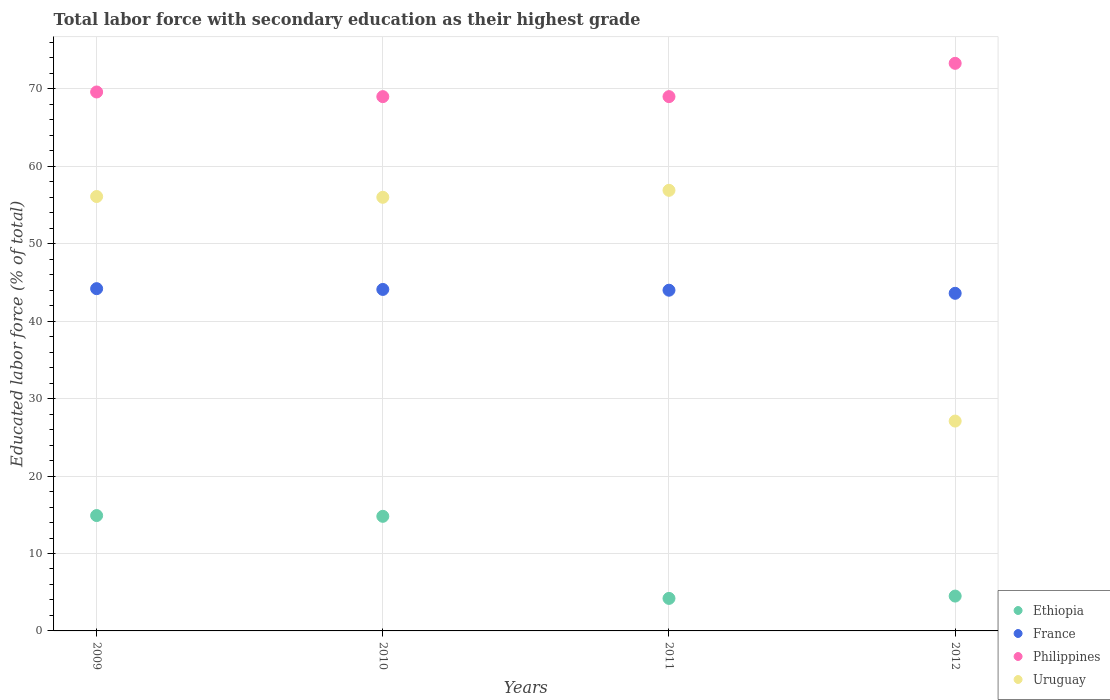What is the percentage of total labor force with primary education in Philippines in 2010?
Give a very brief answer. 69. Across all years, what is the maximum percentage of total labor force with primary education in Ethiopia?
Give a very brief answer. 14.9. Across all years, what is the minimum percentage of total labor force with primary education in Uruguay?
Your answer should be very brief. 27.1. In which year was the percentage of total labor force with primary education in Ethiopia maximum?
Give a very brief answer. 2009. What is the total percentage of total labor force with primary education in Ethiopia in the graph?
Ensure brevity in your answer.  38.4. What is the difference between the percentage of total labor force with primary education in Uruguay in 2009 and that in 2012?
Keep it short and to the point. 29. What is the difference between the percentage of total labor force with primary education in Ethiopia in 2010 and the percentage of total labor force with primary education in Philippines in 2009?
Make the answer very short. -54.8. What is the average percentage of total labor force with primary education in France per year?
Keep it short and to the point. 43.97. In the year 2009, what is the difference between the percentage of total labor force with primary education in Uruguay and percentage of total labor force with primary education in Ethiopia?
Offer a terse response. 41.2. What is the ratio of the percentage of total labor force with primary education in Ethiopia in 2009 to that in 2012?
Your answer should be very brief. 3.31. Is the percentage of total labor force with primary education in Uruguay in 2011 less than that in 2012?
Make the answer very short. No. What is the difference between the highest and the second highest percentage of total labor force with primary education in Uruguay?
Offer a very short reply. 0.8. What is the difference between the highest and the lowest percentage of total labor force with primary education in Ethiopia?
Keep it short and to the point. 10.7. Is the sum of the percentage of total labor force with primary education in Philippines in 2009 and 2010 greater than the maximum percentage of total labor force with primary education in Uruguay across all years?
Make the answer very short. Yes. Is it the case that in every year, the sum of the percentage of total labor force with primary education in Ethiopia and percentage of total labor force with primary education in France  is greater than the percentage of total labor force with primary education in Uruguay?
Provide a short and direct response. No. Is the percentage of total labor force with primary education in Philippines strictly greater than the percentage of total labor force with primary education in Uruguay over the years?
Provide a short and direct response. Yes. How many dotlines are there?
Provide a short and direct response. 4. How many years are there in the graph?
Give a very brief answer. 4. What is the difference between two consecutive major ticks on the Y-axis?
Keep it short and to the point. 10. Are the values on the major ticks of Y-axis written in scientific E-notation?
Your response must be concise. No. Does the graph contain any zero values?
Provide a succinct answer. No. Does the graph contain grids?
Your answer should be compact. Yes. How are the legend labels stacked?
Ensure brevity in your answer.  Vertical. What is the title of the graph?
Make the answer very short. Total labor force with secondary education as their highest grade. Does "French Polynesia" appear as one of the legend labels in the graph?
Provide a succinct answer. No. What is the label or title of the Y-axis?
Your answer should be very brief. Educated labor force (% of total). What is the Educated labor force (% of total) of Ethiopia in 2009?
Keep it short and to the point. 14.9. What is the Educated labor force (% of total) of France in 2009?
Your answer should be compact. 44.2. What is the Educated labor force (% of total) of Philippines in 2009?
Make the answer very short. 69.6. What is the Educated labor force (% of total) in Uruguay in 2009?
Provide a succinct answer. 56.1. What is the Educated labor force (% of total) in Ethiopia in 2010?
Your response must be concise. 14.8. What is the Educated labor force (% of total) in France in 2010?
Give a very brief answer. 44.1. What is the Educated labor force (% of total) in Ethiopia in 2011?
Your answer should be compact. 4.2. What is the Educated labor force (% of total) in France in 2011?
Your answer should be compact. 44. What is the Educated labor force (% of total) in Philippines in 2011?
Offer a terse response. 69. What is the Educated labor force (% of total) in Uruguay in 2011?
Provide a short and direct response. 56.9. What is the Educated labor force (% of total) of Ethiopia in 2012?
Provide a short and direct response. 4.5. What is the Educated labor force (% of total) of France in 2012?
Offer a terse response. 43.6. What is the Educated labor force (% of total) in Philippines in 2012?
Give a very brief answer. 73.3. What is the Educated labor force (% of total) of Uruguay in 2012?
Provide a succinct answer. 27.1. Across all years, what is the maximum Educated labor force (% of total) of Ethiopia?
Provide a short and direct response. 14.9. Across all years, what is the maximum Educated labor force (% of total) in France?
Your answer should be very brief. 44.2. Across all years, what is the maximum Educated labor force (% of total) in Philippines?
Make the answer very short. 73.3. Across all years, what is the maximum Educated labor force (% of total) in Uruguay?
Keep it short and to the point. 56.9. Across all years, what is the minimum Educated labor force (% of total) of Ethiopia?
Your answer should be very brief. 4.2. Across all years, what is the minimum Educated labor force (% of total) in France?
Offer a terse response. 43.6. Across all years, what is the minimum Educated labor force (% of total) in Uruguay?
Keep it short and to the point. 27.1. What is the total Educated labor force (% of total) of Ethiopia in the graph?
Give a very brief answer. 38.4. What is the total Educated labor force (% of total) in France in the graph?
Provide a succinct answer. 175.9. What is the total Educated labor force (% of total) of Philippines in the graph?
Ensure brevity in your answer.  280.9. What is the total Educated labor force (% of total) in Uruguay in the graph?
Provide a short and direct response. 196.1. What is the difference between the Educated labor force (% of total) of Philippines in 2009 and that in 2010?
Your response must be concise. 0.6. What is the difference between the Educated labor force (% of total) of Uruguay in 2009 and that in 2010?
Ensure brevity in your answer.  0.1. What is the difference between the Educated labor force (% of total) in Ethiopia in 2009 and that in 2011?
Ensure brevity in your answer.  10.7. What is the difference between the Educated labor force (% of total) of Uruguay in 2009 and that in 2011?
Provide a succinct answer. -0.8. What is the difference between the Educated labor force (% of total) of Ethiopia in 2009 and that in 2012?
Make the answer very short. 10.4. What is the difference between the Educated labor force (% of total) in Philippines in 2009 and that in 2012?
Your answer should be compact. -3.7. What is the difference between the Educated labor force (% of total) of France in 2010 and that in 2011?
Offer a very short reply. 0.1. What is the difference between the Educated labor force (% of total) in Philippines in 2010 and that in 2011?
Your answer should be compact. 0. What is the difference between the Educated labor force (% of total) of Uruguay in 2010 and that in 2011?
Your answer should be very brief. -0.9. What is the difference between the Educated labor force (% of total) in France in 2010 and that in 2012?
Offer a terse response. 0.5. What is the difference between the Educated labor force (% of total) in Uruguay in 2010 and that in 2012?
Provide a succinct answer. 28.9. What is the difference between the Educated labor force (% of total) in Ethiopia in 2011 and that in 2012?
Offer a terse response. -0.3. What is the difference between the Educated labor force (% of total) of France in 2011 and that in 2012?
Your answer should be very brief. 0.4. What is the difference between the Educated labor force (% of total) of Philippines in 2011 and that in 2012?
Keep it short and to the point. -4.3. What is the difference between the Educated labor force (% of total) in Uruguay in 2011 and that in 2012?
Offer a terse response. 29.8. What is the difference between the Educated labor force (% of total) in Ethiopia in 2009 and the Educated labor force (% of total) in France in 2010?
Give a very brief answer. -29.2. What is the difference between the Educated labor force (% of total) of Ethiopia in 2009 and the Educated labor force (% of total) of Philippines in 2010?
Keep it short and to the point. -54.1. What is the difference between the Educated labor force (% of total) of Ethiopia in 2009 and the Educated labor force (% of total) of Uruguay in 2010?
Offer a terse response. -41.1. What is the difference between the Educated labor force (% of total) in France in 2009 and the Educated labor force (% of total) in Philippines in 2010?
Offer a terse response. -24.8. What is the difference between the Educated labor force (% of total) in Philippines in 2009 and the Educated labor force (% of total) in Uruguay in 2010?
Keep it short and to the point. 13.6. What is the difference between the Educated labor force (% of total) in Ethiopia in 2009 and the Educated labor force (% of total) in France in 2011?
Your answer should be very brief. -29.1. What is the difference between the Educated labor force (% of total) in Ethiopia in 2009 and the Educated labor force (% of total) in Philippines in 2011?
Make the answer very short. -54.1. What is the difference between the Educated labor force (% of total) of Ethiopia in 2009 and the Educated labor force (% of total) of Uruguay in 2011?
Provide a short and direct response. -42. What is the difference between the Educated labor force (% of total) of France in 2009 and the Educated labor force (% of total) of Philippines in 2011?
Give a very brief answer. -24.8. What is the difference between the Educated labor force (% of total) of France in 2009 and the Educated labor force (% of total) of Uruguay in 2011?
Provide a short and direct response. -12.7. What is the difference between the Educated labor force (% of total) in Ethiopia in 2009 and the Educated labor force (% of total) in France in 2012?
Offer a terse response. -28.7. What is the difference between the Educated labor force (% of total) of Ethiopia in 2009 and the Educated labor force (% of total) of Philippines in 2012?
Keep it short and to the point. -58.4. What is the difference between the Educated labor force (% of total) of Ethiopia in 2009 and the Educated labor force (% of total) of Uruguay in 2012?
Keep it short and to the point. -12.2. What is the difference between the Educated labor force (% of total) of France in 2009 and the Educated labor force (% of total) of Philippines in 2012?
Give a very brief answer. -29.1. What is the difference between the Educated labor force (% of total) of Philippines in 2009 and the Educated labor force (% of total) of Uruguay in 2012?
Provide a succinct answer. 42.5. What is the difference between the Educated labor force (% of total) in Ethiopia in 2010 and the Educated labor force (% of total) in France in 2011?
Provide a short and direct response. -29.2. What is the difference between the Educated labor force (% of total) of Ethiopia in 2010 and the Educated labor force (% of total) of Philippines in 2011?
Your answer should be compact. -54.2. What is the difference between the Educated labor force (% of total) in Ethiopia in 2010 and the Educated labor force (% of total) in Uruguay in 2011?
Provide a succinct answer. -42.1. What is the difference between the Educated labor force (% of total) in France in 2010 and the Educated labor force (% of total) in Philippines in 2011?
Make the answer very short. -24.9. What is the difference between the Educated labor force (% of total) in Ethiopia in 2010 and the Educated labor force (% of total) in France in 2012?
Ensure brevity in your answer.  -28.8. What is the difference between the Educated labor force (% of total) of Ethiopia in 2010 and the Educated labor force (% of total) of Philippines in 2012?
Make the answer very short. -58.5. What is the difference between the Educated labor force (% of total) of France in 2010 and the Educated labor force (% of total) of Philippines in 2012?
Your response must be concise. -29.2. What is the difference between the Educated labor force (% of total) in Philippines in 2010 and the Educated labor force (% of total) in Uruguay in 2012?
Make the answer very short. 41.9. What is the difference between the Educated labor force (% of total) of Ethiopia in 2011 and the Educated labor force (% of total) of France in 2012?
Keep it short and to the point. -39.4. What is the difference between the Educated labor force (% of total) in Ethiopia in 2011 and the Educated labor force (% of total) in Philippines in 2012?
Offer a very short reply. -69.1. What is the difference between the Educated labor force (% of total) in Ethiopia in 2011 and the Educated labor force (% of total) in Uruguay in 2012?
Offer a very short reply. -22.9. What is the difference between the Educated labor force (% of total) of France in 2011 and the Educated labor force (% of total) of Philippines in 2012?
Ensure brevity in your answer.  -29.3. What is the difference between the Educated labor force (% of total) in France in 2011 and the Educated labor force (% of total) in Uruguay in 2012?
Your answer should be compact. 16.9. What is the difference between the Educated labor force (% of total) in Philippines in 2011 and the Educated labor force (% of total) in Uruguay in 2012?
Offer a terse response. 41.9. What is the average Educated labor force (% of total) in Ethiopia per year?
Your response must be concise. 9.6. What is the average Educated labor force (% of total) of France per year?
Your answer should be very brief. 43.98. What is the average Educated labor force (% of total) in Philippines per year?
Offer a very short reply. 70.22. What is the average Educated labor force (% of total) in Uruguay per year?
Make the answer very short. 49.02. In the year 2009, what is the difference between the Educated labor force (% of total) in Ethiopia and Educated labor force (% of total) in France?
Your answer should be compact. -29.3. In the year 2009, what is the difference between the Educated labor force (% of total) in Ethiopia and Educated labor force (% of total) in Philippines?
Your answer should be very brief. -54.7. In the year 2009, what is the difference between the Educated labor force (% of total) of Ethiopia and Educated labor force (% of total) of Uruguay?
Ensure brevity in your answer.  -41.2. In the year 2009, what is the difference between the Educated labor force (% of total) of France and Educated labor force (% of total) of Philippines?
Provide a succinct answer. -25.4. In the year 2009, what is the difference between the Educated labor force (% of total) of France and Educated labor force (% of total) of Uruguay?
Your response must be concise. -11.9. In the year 2010, what is the difference between the Educated labor force (% of total) of Ethiopia and Educated labor force (% of total) of France?
Provide a succinct answer. -29.3. In the year 2010, what is the difference between the Educated labor force (% of total) in Ethiopia and Educated labor force (% of total) in Philippines?
Provide a short and direct response. -54.2. In the year 2010, what is the difference between the Educated labor force (% of total) in Ethiopia and Educated labor force (% of total) in Uruguay?
Give a very brief answer. -41.2. In the year 2010, what is the difference between the Educated labor force (% of total) of France and Educated labor force (% of total) of Philippines?
Your answer should be compact. -24.9. In the year 2010, what is the difference between the Educated labor force (% of total) of France and Educated labor force (% of total) of Uruguay?
Keep it short and to the point. -11.9. In the year 2010, what is the difference between the Educated labor force (% of total) in Philippines and Educated labor force (% of total) in Uruguay?
Your response must be concise. 13. In the year 2011, what is the difference between the Educated labor force (% of total) in Ethiopia and Educated labor force (% of total) in France?
Your response must be concise. -39.8. In the year 2011, what is the difference between the Educated labor force (% of total) of Ethiopia and Educated labor force (% of total) of Philippines?
Keep it short and to the point. -64.8. In the year 2011, what is the difference between the Educated labor force (% of total) in Ethiopia and Educated labor force (% of total) in Uruguay?
Provide a short and direct response. -52.7. In the year 2011, what is the difference between the Educated labor force (% of total) of France and Educated labor force (% of total) of Philippines?
Make the answer very short. -25. In the year 2012, what is the difference between the Educated labor force (% of total) in Ethiopia and Educated labor force (% of total) in France?
Ensure brevity in your answer.  -39.1. In the year 2012, what is the difference between the Educated labor force (% of total) of Ethiopia and Educated labor force (% of total) of Philippines?
Make the answer very short. -68.8. In the year 2012, what is the difference between the Educated labor force (% of total) of Ethiopia and Educated labor force (% of total) of Uruguay?
Offer a very short reply. -22.6. In the year 2012, what is the difference between the Educated labor force (% of total) in France and Educated labor force (% of total) in Philippines?
Ensure brevity in your answer.  -29.7. In the year 2012, what is the difference between the Educated labor force (% of total) of Philippines and Educated labor force (% of total) of Uruguay?
Offer a very short reply. 46.2. What is the ratio of the Educated labor force (% of total) of Ethiopia in 2009 to that in 2010?
Keep it short and to the point. 1.01. What is the ratio of the Educated labor force (% of total) in France in 2009 to that in 2010?
Make the answer very short. 1. What is the ratio of the Educated labor force (% of total) of Philippines in 2009 to that in 2010?
Your answer should be compact. 1.01. What is the ratio of the Educated labor force (% of total) in Ethiopia in 2009 to that in 2011?
Make the answer very short. 3.55. What is the ratio of the Educated labor force (% of total) in Philippines in 2009 to that in 2011?
Give a very brief answer. 1.01. What is the ratio of the Educated labor force (% of total) in Uruguay in 2009 to that in 2011?
Give a very brief answer. 0.99. What is the ratio of the Educated labor force (% of total) of Ethiopia in 2009 to that in 2012?
Provide a short and direct response. 3.31. What is the ratio of the Educated labor force (% of total) of France in 2009 to that in 2012?
Your answer should be compact. 1.01. What is the ratio of the Educated labor force (% of total) of Philippines in 2009 to that in 2012?
Give a very brief answer. 0.95. What is the ratio of the Educated labor force (% of total) in Uruguay in 2009 to that in 2012?
Your response must be concise. 2.07. What is the ratio of the Educated labor force (% of total) in Ethiopia in 2010 to that in 2011?
Provide a succinct answer. 3.52. What is the ratio of the Educated labor force (% of total) in Philippines in 2010 to that in 2011?
Ensure brevity in your answer.  1. What is the ratio of the Educated labor force (% of total) in Uruguay in 2010 to that in 2011?
Offer a very short reply. 0.98. What is the ratio of the Educated labor force (% of total) in Ethiopia in 2010 to that in 2012?
Provide a short and direct response. 3.29. What is the ratio of the Educated labor force (% of total) in France in 2010 to that in 2012?
Provide a short and direct response. 1.01. What is the ratio of the Educated labor force (% of total) of Philippines in 2010 to that in 2012?
Offer a very short reply. 0.94. What is the ratio of the Educated labor force (% of total) of Uruguay in 2010 to that in 2012?
Your answer should be compact. 2.07. What is the ratio of the Educated labor force (% of total) in Ethiopia in 2011 to that in 2012?
Your answer should be compact. 0.93. What is the ratio of the Educated labor force (% of total) of France in 2011 to that in 2012?
Keep it short and to the point. 1.01. What is the ratio of the Educated labor force (% of total) of Philippines in 2011 to that in 2012?
Your answer should be very brief. 0.94. What is the ratio of the Educated labor force (% of total) in Uruguay in 2011 to that in 2012?
Offer a very short reply. 2.1. What is the difference between the highest and the second highest Educated labor force (% of total) in Ethiopia?
Provide a short and direct response. 0.1. What is the difference between the highest and the lowest Educated labor force (% of total) of France?
Provide a succinct answer. 0.6. What is the difference between the highest and the lowest Educated labor force (% of total) of Uruguay?
Your answer should be compact. 29.8. 